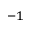<formula> <loc_0><loc_0><loc_500><loc_500>^ { - 1 }</formula> 